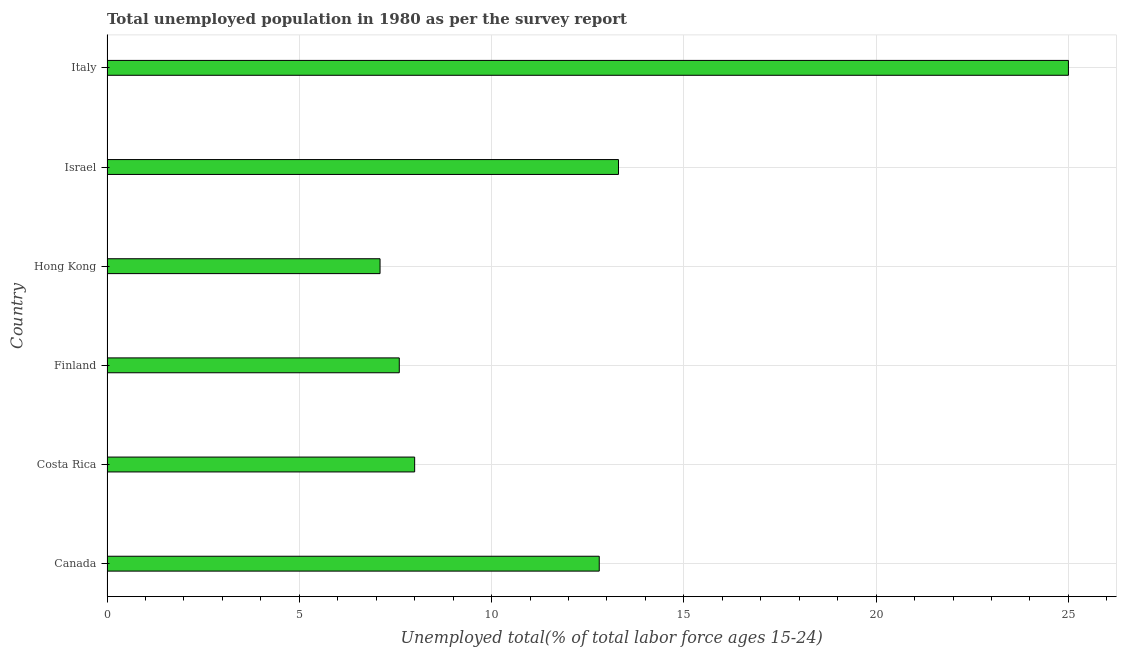Does the graph contain grids?
Ensure brevity in your answer.  Yes. What is the title of the graph?
Provide a succinct answer. Total unemployed population in 1980 as per the survey report. What is the label or title of the X-axis?
Keep it short and to the point. Unemployed total(% of total labor force ages 15-24). What is the label or title of the Y-axis?
Your answer should be compact. Country. What is the unemployed youth in Finland?
Provide a short and direct response. 7.6. Across all countries, what is the minimum unemployed youth?
Your response must be concise. 7.1. In which country was the unemployed youth maximum?
Your response must be concise. Italy. In which country was the unemployed youth minimum?
Ensure brevity in your answer.  Hong Kong. What is the sum of the unemployed youth?
Ensure brevity in your answer.  73.8. What is the average unemployed youth per country?
Offer a terse response. 12.3. What is the median unemployed youth?
Ensure brevity in your answer.  10.4. What is the ratio of the unemployed youth in Costa Rica to that in Finland?
Your answer should be very brief. 1.05. Is the difference between the unemployed youth in Finland and Italy greater than the difference between any two countries?
Your answer should be compact. No. Is the sum of the unemployed youth in Canada and Hong Kong greater than the maximum unemployed youth across all countries?
Provide a short and direct response. No. What is the difference between the highest and the lowest unemployed youth?
Your answer should be very brief. 17.9. In how many countries, is the unemployed youth greater than the average unemployed youth taken over all countries?
Your answer should be very brief. 3. Are all the bars in the graph horizontal?
Make the answer very short. Yes. How many countries are there in the graph?
Your response must be concise. 6. What is the difference between two consecutive major ticks on the X-axis?
Offer a terse response. 5. What is the Unemployed total(% of total labor force ages 15-24) of Canada?
Keep it short and to the point. 12.8. What is the Unemployed total(% of total labor force ages 15-24) of Finland?
Give a very brief answer. 7.6. What is the Unemployed total(% of total labor force ages 15-24) of Hong Kong?
Your answer should be very brief. 7.1. What is the Unemployed total(% of total labor force ages 15-24) in Israel?
Your answer should be compact. 13.3. What is the difference between the Unemployed total(% of total labor force ages 15-24) in Canada and Hong Kong?
Provide a short and direct response. 5.7. What is the difference between the Unemployed total(% of total labor force ages 15-24) in Canada and Israel?
Make the answer very short. -0.5. What is the difference between the Unemployed total(% of total labor force ages 15-24) in Costa Rica and Italy?
Your response must be concise. -17. What is the difference between the Unemployed total(% of total labor force ages 15-24) in Finland and Hong Kong?
Provide a succinct answer. 0.5. What is the difference between the Unemployed total(% of total labor force ages 15-24) in Finland and Italy?
Give a very brief answer. -17.4. What is the difference between the Unemployed total(% of total labor force ages 15-24) in Hong Kong and Italy?
Your response must be concise. -17.9. What is the difference between the Unemployed total(% of total labor force ages 15-24) in Israel and Italy?
Provide a succinct answer. -11.7. What is the ratio of the Unemployed total(% of total labor force ages 15-24) in Canada to that in Finland?
Ensure brevity in your answer.  1.68. What is the ratio of the Unemployed total(% of total labor force ages 15-24) in Canada to that in Hong Kong?
Give a very brief answer. 1.8. What is the ratio of the Unemployed total(% of total labor force ages 15-24) in Canada to that in Italy?
Ensure brevity in your answer.  0.51. What is the ratio of the Unemployed total(% of total labor force ages 15-24) in Costa Rica to that in Finland?
Keep it short and to the point. 1.05. What is the ratio of the Unemployed total(% of total labor force ages 15-24) in Costa Rica to that in Hong Kong?
Keep it short and to the point. 1.13. What is the ratio of the Unemployed total(% of total labor force ages 15-24) in Costa Rica to that in Israel?
Ensure brevity in your answer.  0.6. What is the ratio of the Unemployed total(% of total labor force ages 15-24) in Costa Rica to that in Italy?
Your answer should be compact. 0.32. What is the ratio of the Unemployed total(% of total labor force ages 15-24) in Finland to that in Hong Kong?
Provide a short and direct response. 1.07. What is the ratio of the Unemployed total(% of total labor force ages 15-24) in Finland to that in Israel?
Offer a terse response. 0.57. What is the ratio of the Unemployed total(% of total labor force ages 15-24) in Finland to that in Italy?
Ensure brevity in your answer.  0.3. What is the ratio of the Unemployed total(% of total labor force ages 15-24) in Hong Kong to that in Israel?
Provide a short and direct response. 0.53. What is the ratio of the Unemployed total(% of total labor force ages 15-24) in Hong Kong to that in Italy?
Offer a terse response. 0.28. What is the ratio of the Unemployed total(% of total labor force ages 15-24) in Israel to that in Italy?
Your answer should be very brief. 0.53. 